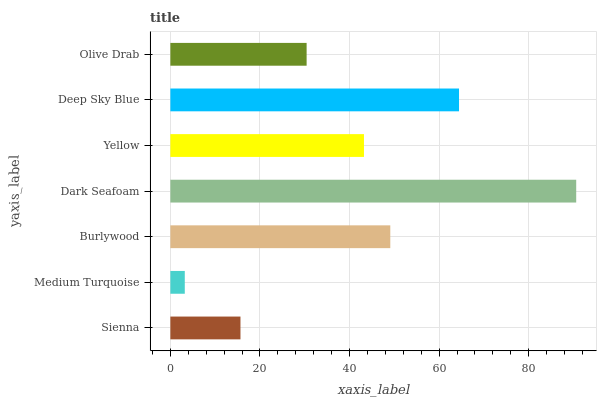Is Medium Turquoise the minimum?
Answer yes or no. Yes. Is Dark Seafoam the maximum?
Answer yes or no. Yes. Is Burlywood the minimum?
Answer yes or no. No. Is Burlywood the maximum?
Answer yes or no. No. Is Burlywood greater than Medium Turquoise?
Answer yes or no. Yes. Is Medium Turquoise less than Burlywood?
Answer yes or no. Yes. Is Medium Turquoise greater than Burlywood?
Answer yes or no. No. Is Burlywood less than Medium Turquoise?
Answer yes or no. No. Is Yellow the high median?
Answer yes or no. Yes. Is Yellow the low median?
Answer yes or no. Yes. Is Olive Drab the high median?
Answer yes or no. No. Is Medium Turquoise the low median?
Answer yes or no. No. 